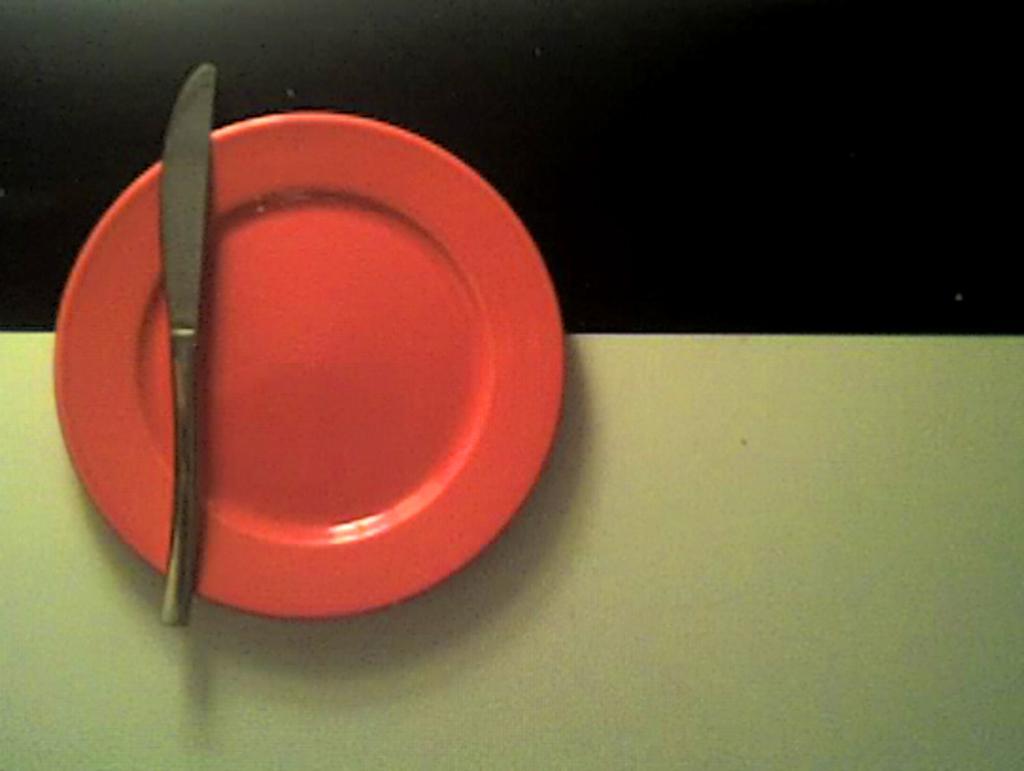Could you give a brief overview of what you see in this image? There is a knife on the orange color plate which is on the white color surface. And the background is dark in color. 